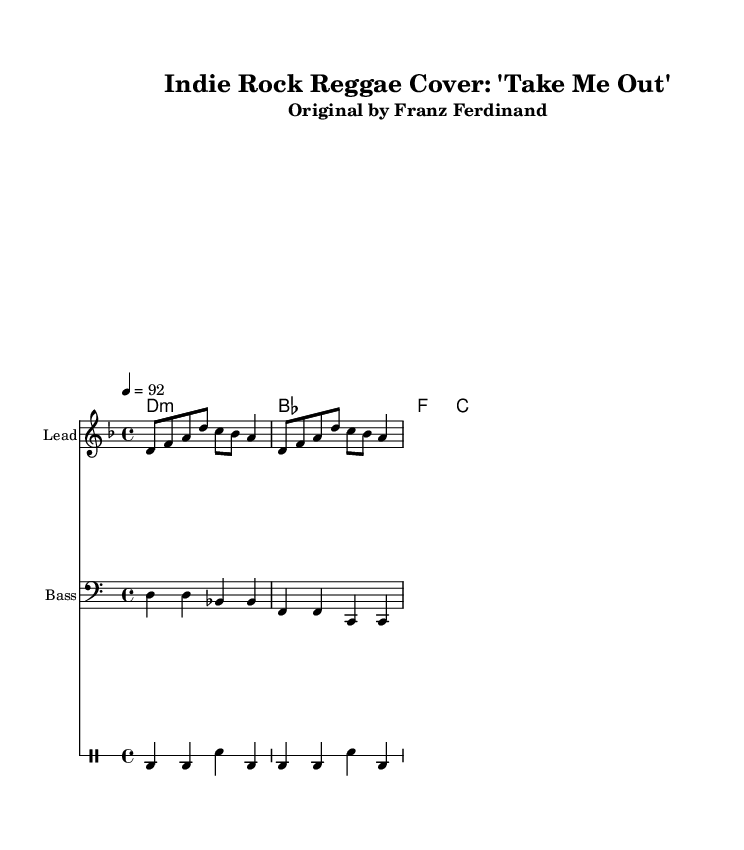What is the time signature of this music? The time signature is displayed as "4/4" at the beginning of the score. This indicates that there are four beats in each measure, and the quarter note receives one beat.
Answer: 4/4 What is the tempo marking found in the music? The tempo marking is indicated as "4 = 92," meaning the quarter note should be played at a speed of 92 beats per minute.
Answer: 92 What is the key signature of this sheet music? The key signature is D minor, which is identified by the "d" at the start of the global settings. D minor has one flat, B flat, in its key signature.
Answer: D minor How many measures are shown in the melody section? The melody section consists of two distinct phrases, and there are four measures that can be counted in the provided melody.
Answer: 4 What instrument is designated for the lead part? The Instrument designated for the lead part is marked at the beginning of the corresponding staff as "Lead." This identifies the primary melody instrument.
Answer: Lead What type of musical style is represented by this arrangement? The arrangement style is Reggae, which is evident from the rhythmic patterns of the drums and the feel of the bass line. Additionally, it is a cover version of an indie rock song, which is a characteristic fusion for reggae covers.
Answer: Reggae How is the harmonic structure established in this music piece? The harmonic structure uses chord symbols in the "harmonies" section, clearly labeled with D minor and related chords, providing context for the melody. The chord mode notation indicates that these chords underpin the melody line.
Answer: Chord symbols 